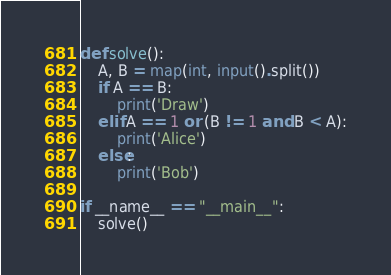<code> <loc_0><loc_0><loc_500><loc_500><_Python_>def solve():
    A, B = map(int, input().split())
    if A == B:
        print('Draw')
    elif A == 1 or (B != 1 and B < A):
        print('Alice')
    else:
        print('Bob')

if __name__ == "__main__":
    solve()</code> 